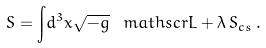<formula> <loc_0><loc_0><loc_500><loc_500>S = { \int } d ^ { 3 } x \sqrt { - g } \, \ m a t h s c r { L } + \lambda \, S _ { c s } \, .</formula> 